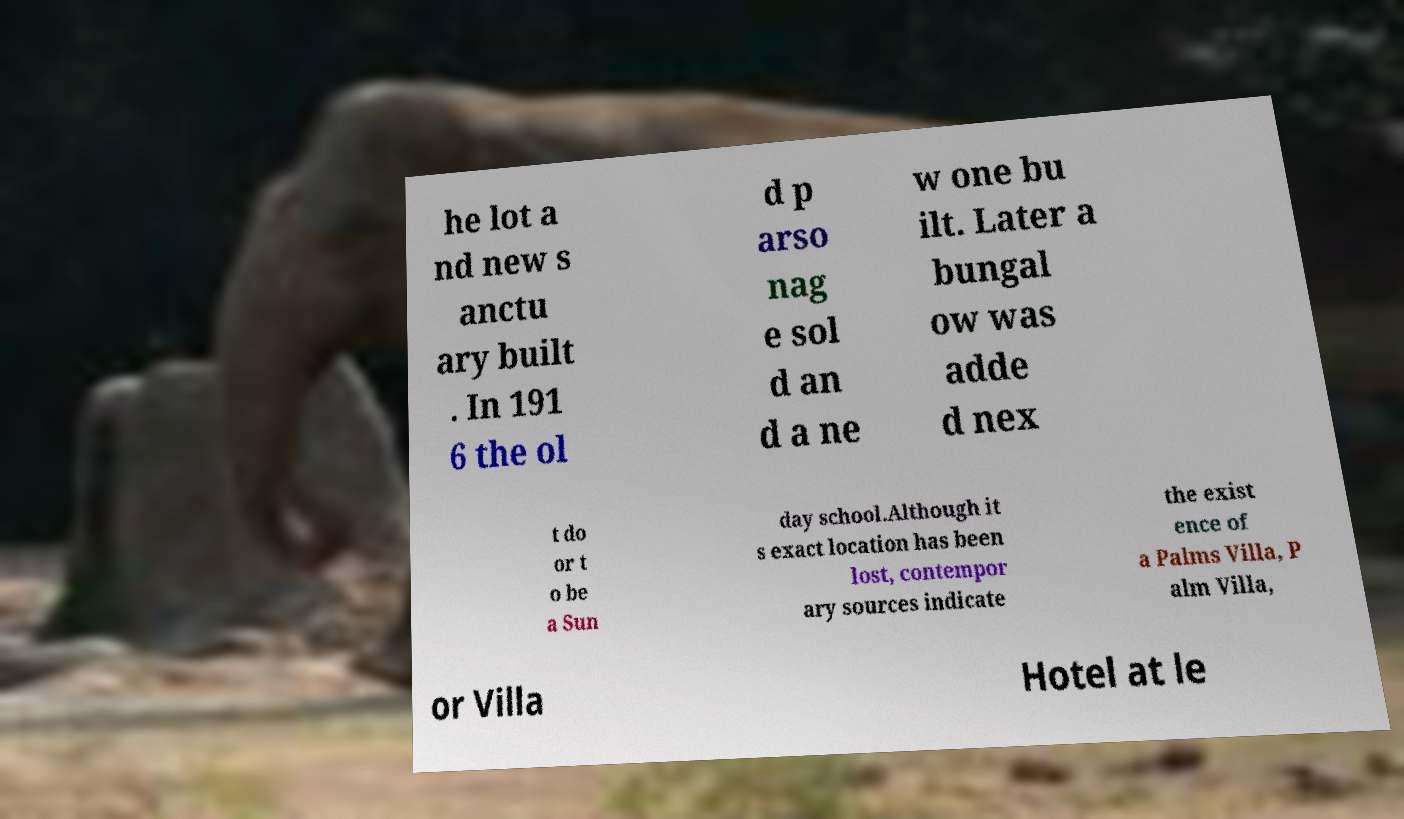There's text embedded in this image that I need extracted. Can you transcribe it verbatim? he lot a nd new s anctu ary built . In 191 6 the ol d p arso nag e sol d an d a ne w one bu ilt. Later a bungal ow was adde d nex t do or t o be a Sun day school.Although it s exact location has been lost, contempor ary sources indicate the exist ence of a Palms Villa, P alm Villa, or Villa Hotel at le 